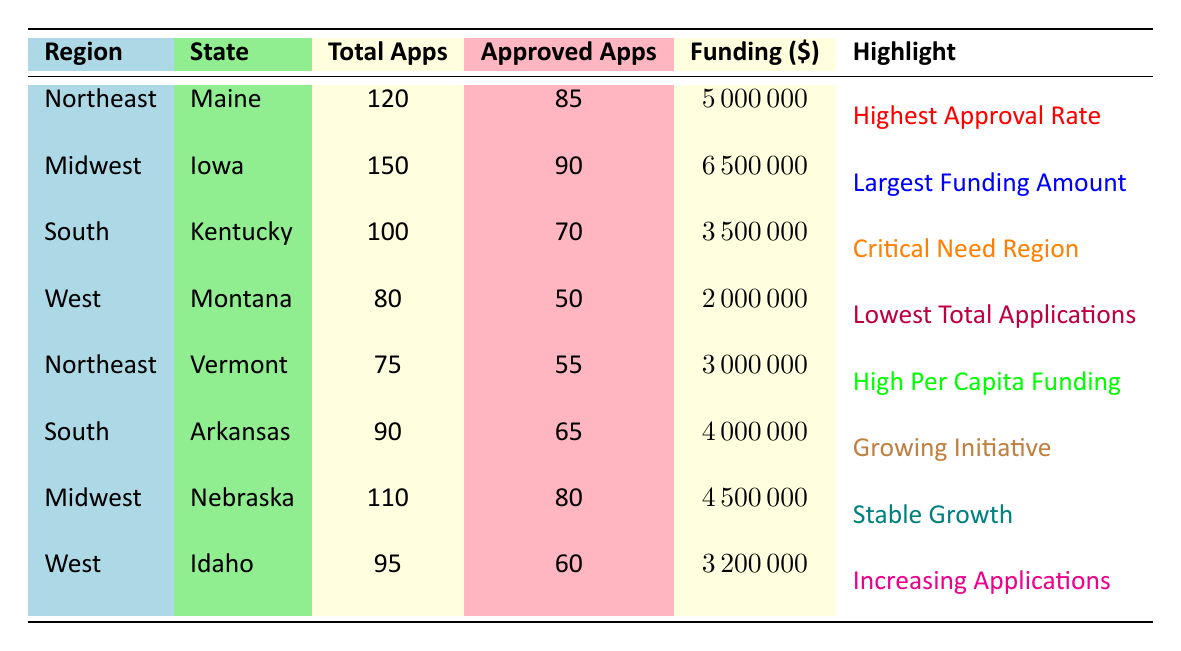What is the highest funding amount for a state from the table? The table shows Iowa has the highest funding amount of 6,500,000 dollars.
Answer: 6,500,000 Which region has the lowest total applications according to the table? The table indicates that Montana has the lowest total applications with 80 applications.
Answer: Montana How many approved applications were there in the South region? In the South region, Kentucky had 70 approved applications and Arkansas had 65 approved applications. So, the total is 70 + 65 = 135 approved applications.
Answer: 135 Is Vermont’s funding amount higher than Idaho's? Vermont's funding amount is 3,000,000 dollars and Idaho's is 3,200,000 dollars. Since 3,000,000 is not greater than 3,200,000, the answer is no.
Answer: No What is the difference in total applications between Iowa and Nebraska? Iowa has 150 total applications and Nebraska has 110 total applications. The difference is 150 - 110 = 40.
Answer: 40 Which state has both the highest approval rate and the highest funding amount? Maine has the highest approval rate of 85 out of 120 applications, but Iowa has the highest funding amount of 6,500,000 dollars. Therefore, no state has both attributes.
Answer: None Calculate the average funding amount for the Midwest region. The Midwest region includes Iowa with 6,500,000 and Nebraska with 4,500,000. The total funding amount is 6,500,000 + 4,500,000 = 11,000,000. The average is 11,000,000 divided by 2, giving 5,500,000.
Answer: 5,500,000 Which state has the highest approval rate and what is that percentage? Maine has 85 approved applications from 120 total applications, so the approval rate is (85/120) * 100 ≈ 70.83%.
Answer: 70.83% How many states in the West region have over 60 approved applications? The West region has Montana with 50 and Idaho with 60 approved applications, so neither state has over 60 approved applications.
Answer: 0 Compare the funding amounts of Kentucky and Arkansas; which is higher and by how much? Kentucky received 3,500,000 dollars and Arkansas received 4,000,000 dollars. The difference is 4,000,000 - 3,500,000 = 500,000, meaning Arkansas has the higher amount.
Answer: Arkansas is higher by 500,000 